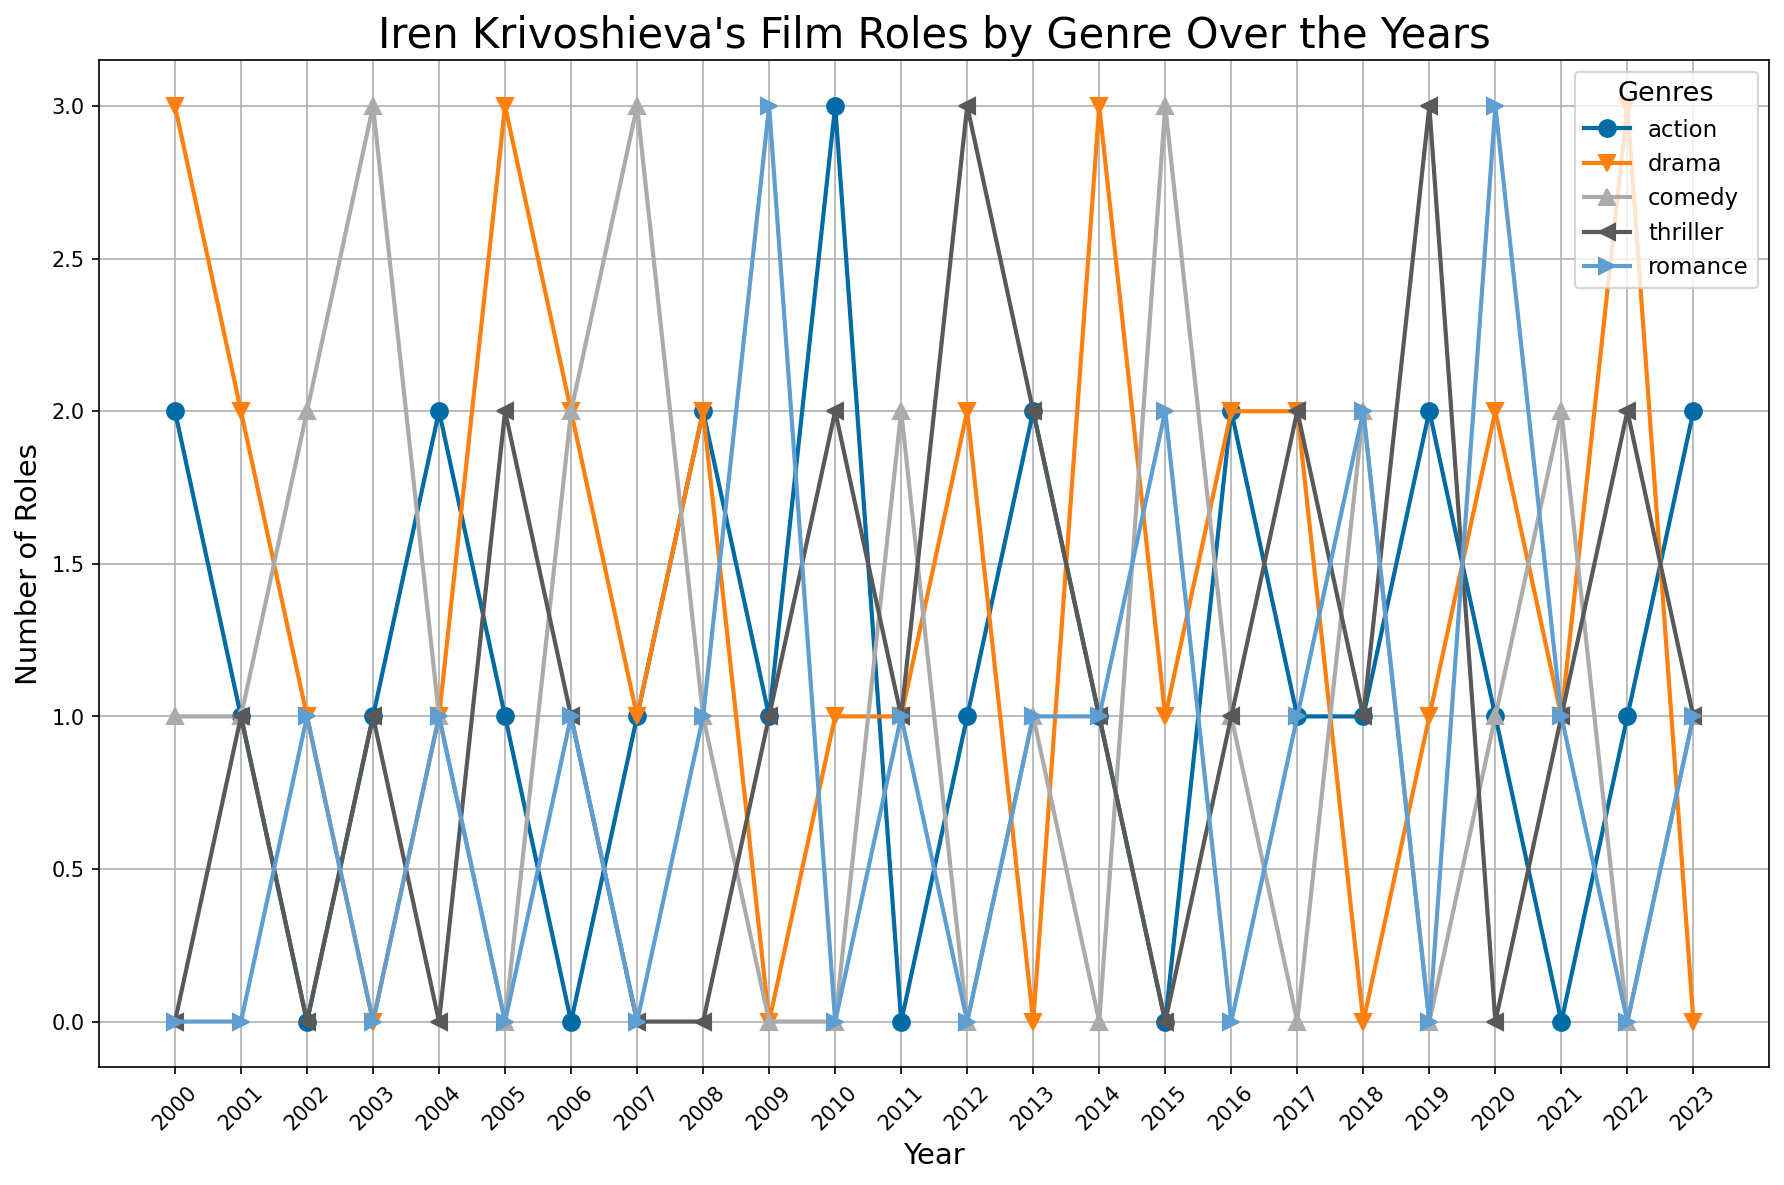When did Iren Krivoshieva take on the most action roles in a year? Find the peak value along the 'action' genre line and identify the corresponding year. The peak value for action roles is 3, which occurs in 2010.
Answer: 2010 In which year did Iren Krivoshieva have an equal number of roles in drama and comedy? Compare the number of drama and comedy roles for each year and identify when they are equal. In 2006, Iren had 2 roles in drama and 2 roles in comedy.
Answer: 2006 What is the total number of romance roles Iren Krivoshieva played from 2000 to 2023? Sum up the values in the 'romance' column. The sum is 0 + 0 + 1 + 0 + 1 + 0 + 1 + 0 + 1 + 3 + 0 + 1 + 0 + 1 + 2 + 0 + 1 + 2 + 0 + 3 + 1 + 0 + 1 = 19.
Answer: 19 Which genre saw a decrease in the number of roles from 2000 to 2001? Compare the number of roles from 2000 to 2001 for all genres and identify any decreases. The number of action roles decreased from 2 to 1, and drama roles decreased from 3 to 2.
Answer: Action and Drama Between 2007 and 2013, which genre had the highest number of roles in a single year? For each year from 2007 to 2013, identify the genre with the maximum roles and then find the highest among those values. Comedy had 3 roles in 2007.
Answer: Comedy How many years did Iren Krivoshieva play at least 3 roles in any genre? Check each year to see if there is any genre with 3 or more roles and count those years. The years are 2010, 2005, 2012, 2019, 2000, 2009, 2010, 2014.
Answer: 8 Did Iren Krivoshieva ever play roles in all five genres in a single year? Check each year to see if all five genre values are greater than 0. No year has roles in all five genres.
Answer: No What is the average number of drama roles per year between 2000 and 2023? Sum the values in the 'drama' column and divide by the number of years. The sum is 35, and there are 24 years, so the average is 35/24 ≈ 1.46.
Answer: 1.46 Which year had the most diverse genre spread in terms of roles? Determine the year with the highest number of distinct genre roles, considering even distributions. 2001, 2006, 2016 have 4 roles each in four different genres.
Answer: 2001, 2006, and 2016 What is the trend in the number of thriller roles from 2010 to 2013? Examine the values in the 'thriller' column from 2010 to 2013 and describe the trend. The values are 2, 1, 3, 2, showing a fluctuating trend.
Answer: Fluctuating 